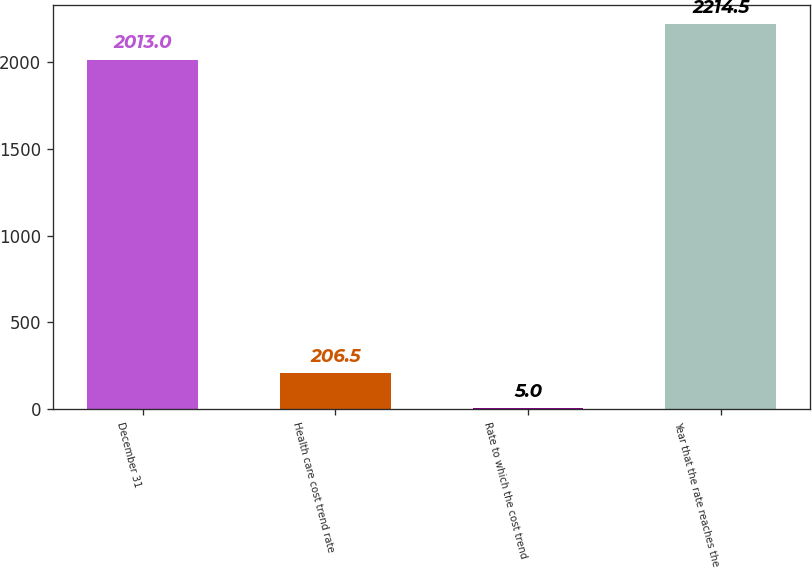Convert chart to OTSL. <chart><loc_0><loc_0><loc_500><loc_500><bar_chart><fcel>December 31<fcel>Health care cost trend rate<fcel>Rate to which the cost trend<fcel>Year that the rate reaches the<nl><fcel>2013<fcel>206.5<fcel>5<fcel>2214.5<nl></chart> 